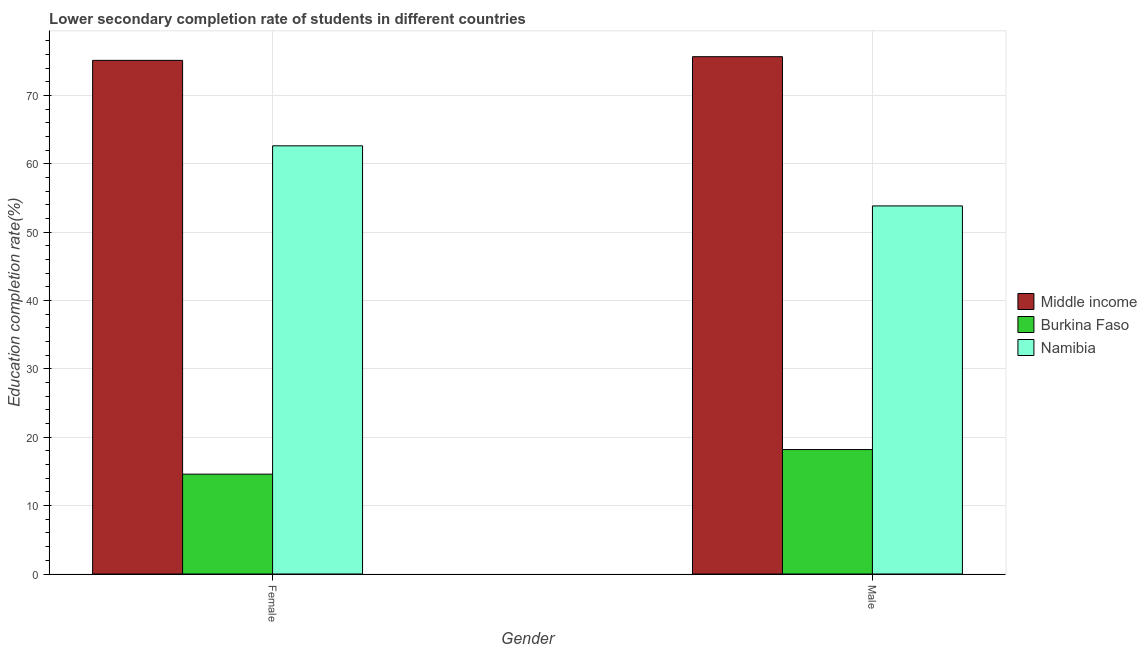How many groups of bars are there?
Your response must be concise. 2. Are the number of bars per tick equal to the number of legend labels?
Keep it short and to the point. Yes. How many bars are there on the 2nd tick from the right?
Ensure brevity in your answer.  3. What is the education completion rate of male students in Namibia?
Provide a succinct answer. 53.86. Across all countries, what is the maximum education completion rate of male students?
Give a very brief answer. 75.69. Across all countries, what is the minimum education completion rate of male students?
Provide a succinct answer. 18.21. In which country was the education completion rate of female students maximum?
Offer a very short reply. Middle income. In which country was the education completion rate of male students minimum?
Offer a terse response. Burkina Faso. What is the total education completion rate of male students in the graph?
Offer a terse response. 147.76. What is the difference between the education completion rate of male students in Namibia and that in Middle income?
Your answer should be compact. -21.83. What is the difference between the education completion rate of female students in Middle income and the education completion rate of male students in Burkina Faso?
Your answer should be very brief. 56.95. What is the average education completion rate of male students per country?
Ensure brevity in your answer.  49.25. What is the difference between the education completion rate of female students and education completion rate of male students in Namibia?
Your answer should be compact. 8.79. In how many countries, is the education completion rate of female students greater than 50 %?
Give a very brief answer. 2. What is the ratio of the education completion rate of female students in Middle income to that in Burkina Faso?
Provide a short and direct response. 5.14. In how many countries, is the education completion rate of female students greater than the average education completion rate of female students taken over all countries?
Your answer should be compact. 2. What does the 1st bar from the left in Female represents?
Provide a short and direct response. Middle income. What does the 2nd bar from the right in Male represents?
Make the answer very short. Burkina Faso. What is the difference between two consecutive major ticks on the Y-axis?
Provide a short and direct response. 10. Are the values on the major ticks of Y-axis written in scientific E-notation?
Offer a very short reply. No. What is the title of the graph?
Provide a succinct answer. Lower secondary completion rate of students in different countries. What is the label or title of the Y-axis?
Keep it short and to the point. Education completion rate(%). What is the Education completion rate(%) of Middle income in Female?
Provide a short and direct response. 75.15. What is the Education completion rate(%) in Burkina Faso in Female?
Offer a very short reply. 14.61. What is the Education completion rate(%) of Namibia in Female?
Make the answer very short. 62.65. What is the Education completion rate(%) in Middle income in Male?
Give a very brief answer. 75.69. What is the Education completion rate(%) of Burkina Faso in Male?
Your answer should be very brief. 18.21. What is the Education completion rate(%) in Namibia in Male?
Offer a terse response. 53.86. Across all Gender, what is the maximum Education completion rate(%) in Middle income?
Your response must be concise. 75.69. Across all Gender, what is the maximum Education completion rate(%) of Burkina Faso?
Keep it short and to the point. 18.21. Across all Gender, what is the maximum Education completion rate(%) of Namibia?
Your answer should be very brief. 62.65. Across all Gender, what is the minimum Education completion rate(%) of Middle income?
Provide a short and direct response. 75.15. Across all Gender, what is the minimum Education completion rate(%) in Burkina Faso?
Ensure brevity in your answer.  14.61. Across all Gender, what is the minimum Education completion rate(%) in Namibia?
Ensure brevity in your answer.  53.86. What is the total Education completion rate(%) in Middle income in the graph?
Provide a short and direct response. 150.85. What is the total Education completion rate(%) in Burkina Faso in the graph?
Offer a terse response. 32.82. What is the total Education completion rate(%) in Namibia in the graph?
Offer a very short reply. 116.51. What is the difference between the Education completion rate(%) of Middle income in Female and that in Male?
Provide a succinct answer. -0.54. What is the difference between the Education completion rate(%) of Burkina Faso in Female and that in Male?
Your answer should be very brief. -3.6. What is the difference between the Education completion rate(%) in Namibia in Female and that in Male?
Your answer should be compact. 8.79. What is the difference between the Education completion rate(%) of Middle income in Female and the Education completion rate(%) of Burkina Faso in Male?
Provide a succinct answer. 56.95. What is the difference between the Education completion rate(%) of Middle income in Female and the Education completion rate(%) of Namibia in Male?
Offer a very short reply. 21.3. What is the difference between the Education completion rate(%) of Burkina Faso in Female and the Education completion rate(%) of Namibia in Male?
Your answer should be compact. -39.25. What is the average Education completion rate(%) in Middle income per Gender?
Your answer should be compact. 75.42. What is the average Education completion rate(%) of Burkina Faso per Gender?
Provide a succinct answer. 16.41. What is the average Education completion rate(%) in Namibia per Gender?
Your answer should be compact. 58.25. What is the difference between the Education completion rate(%) in Middle income and Education completion rate(%) in Burkina Faso in Female?
Ensure brevity in your answer.  60.54. What is the difference between the Education completion rate(%) of Middle income and Education completion rate(%) of Namibia in Female?
Your answer should be compact. 12.5. What is the difference between the Education completion rate(%) in Burkina Faso and Education completion rate(%) in Namibia in Female?
Provide a succinct answer. -48.04. What is the difference between the Education completion rate(%) of Middle income and Education completion rate(%) of Burkina Faso in Male?
Your answer should be very brief. 57.48. What is the difference between the Education completion rate(%) in Middle income and Education completion rate(%) in Namibia in Male?
Ensure brevity in your answer.  21.83. What is the difference between the Education completion rate(%) of Burkina Faso and Education completion rate(%) of Namibia in Male?
Give a very brief answer. -35.65. What is the ratio of the Education completion rate(%) of Middle income in Female to that in Male?
Offer a very short reply. 0.99. What is the ratio of the Education completion rate(%) of Burkina Faso in Female to that in Male?
Your response must be concise. 0.8. What is the ratio of the Education completion rate(%) of Namibia in Female to that in Male?
Keep it short and to the point. 1.16. What is the difference between the highest and the second highest Education completion rate(%) in Middle income?
Give a very brief answer. 0.54. What is the difference between the highest and the second highest Education completion rate(%) of Burkina Faso?
Make the answer very short. 3.6. What is the difference between the highest and the second highest Education completion rate(%) of Namibia?
Your answer should be compact. 8.79. What is the difference between the highest and the lowest Education completion rate(%) in Middle income?
Your answer should be compact. 0.54. What is the difference between the highest and the lowest Education completion rate(%) in Burkina Faso?
Offer a terse response. 3.6. What is the difference between the highest and the lowest Education completion rate(%) in Namibia?
Provide a short and direct response. 8.79. 